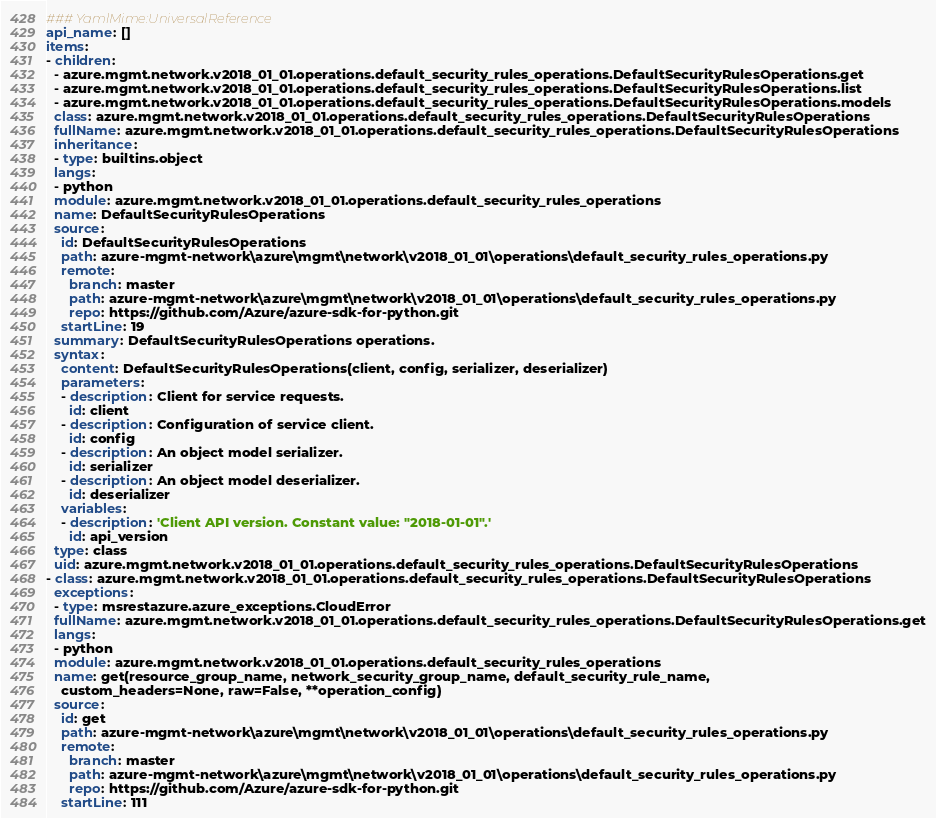<code> <loc_0><loc_0><loc_500><loc_500><_YAML_>### YamlMime:UniversalReference
api_name: []
items:
- children:
  - azure.mgmt.network.v2018_01_01.operations.default_security_rules_operations.DefaultSecurityRulesOperations.get
  - azure.mgmt.network.v2018_01_01.operations.default_security_rules_operations.DefaultSecurityRulesOperations.list
  - azure.mgmt.network.v2018_01_01.operations.default_security_rules_operations.DefaultSecurityRulesOperations.models
  class: azure.mgmt.network.v2018_01_01.operations.default_security_rules_operations.DefaultSecurityRulesOperations
  fullName: azure.mgmt.network.v2018_01_01.operations.default_security_rules_operations.DefaultSecurityRulesOperations
  inheritance:
  - type: builtins.object
  langs:
  - python
  module: azure.mgmt.network.v2018_01_01.operations.default_security_rules_operations
  name: DefaultSecurityRulesOperations
  source:
    id: DefaultSecurityRulesOperations
    path: azure-mgmt-network\azure\mgmt\network\v2018_01_01\operations\default_security_rules_operations.py
    remote:
      branch: master
      path: azure-mgmt-network\azure\mgmt\network\v2018_01_01\operations\default_security_rules_operations.py
      repo: https://github.com/Azure/azure-sdk-for-python.git
    startLine: 19
  summary: DefaultSecurityRulesOperations operations.
  syntax:
    content: DefaultSecurityRulesOperations(client, config, serializer, deserializer)
    parameters:
    - description: Client for service requests.
      id: client
    - description: Configuration of service client.
      id: config
    - description: An object model serializer.
      id: serializer
    - description: An object model deserializer.
      id: deserializer
    variables:
    - description: 'Client API version. Constant value: "2018-01-01".'
      id: api_version
  type: class
  uid: azure.mgmt.network.v2018_01_01.operations.default_security_rules_operations.DefaultSecurityRulesOperations
- class: azure.mgmt.network.v2018_01_01.operations.default_security_rules_operations.DefaultSecurityRulesOperations
  exceptions:
  - type: msrestazure.azure_exceptions.CloudError
  fullName: azure.mgmt.network.v2018_01_01.operations.default_security_rules_operations.DefaultSecurityRulesOperations.get
  langs:
  - python
  module: azure.mgmt.network.v2018_01_01.operations.default_security_rules_operations
  name: get(resource_group_name, network_security_group_name, default_security_rule_name,
    custom_headers=None, raw=False, **operation_config)
  source:
    id: get
    path: azure-mgmt-network\azure\mgmt\network\v2018_01_01\operations\default_security_rules_operations.py
    remote:
      branch: master
      path: azure-mgmt-network\azure\mgmt\network\v2018_01_01\operations\default_security_rules_operations.py
      repo: https://github.com/Azure/azure-sdk-for-python.git
    startLine: 111</code> 